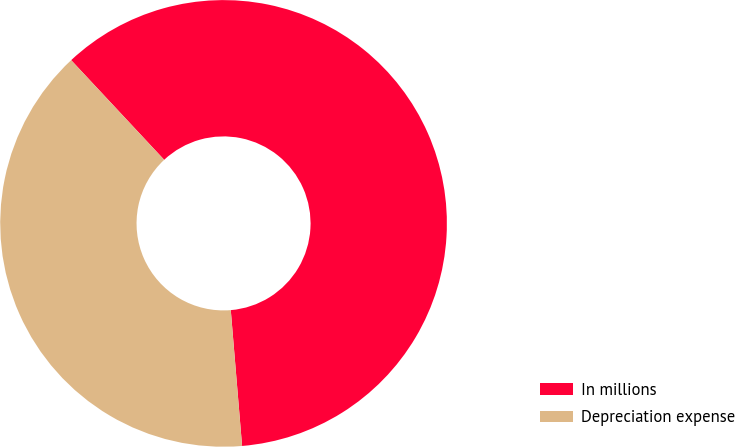Convert chart. <chart><loc_0><loc_0><loc_500><loc_500><pie_chart><fcel>In millions<fcel>Depreciation expense<nl><fcel>60.63%<fcel>39.37%<nl></chart> 